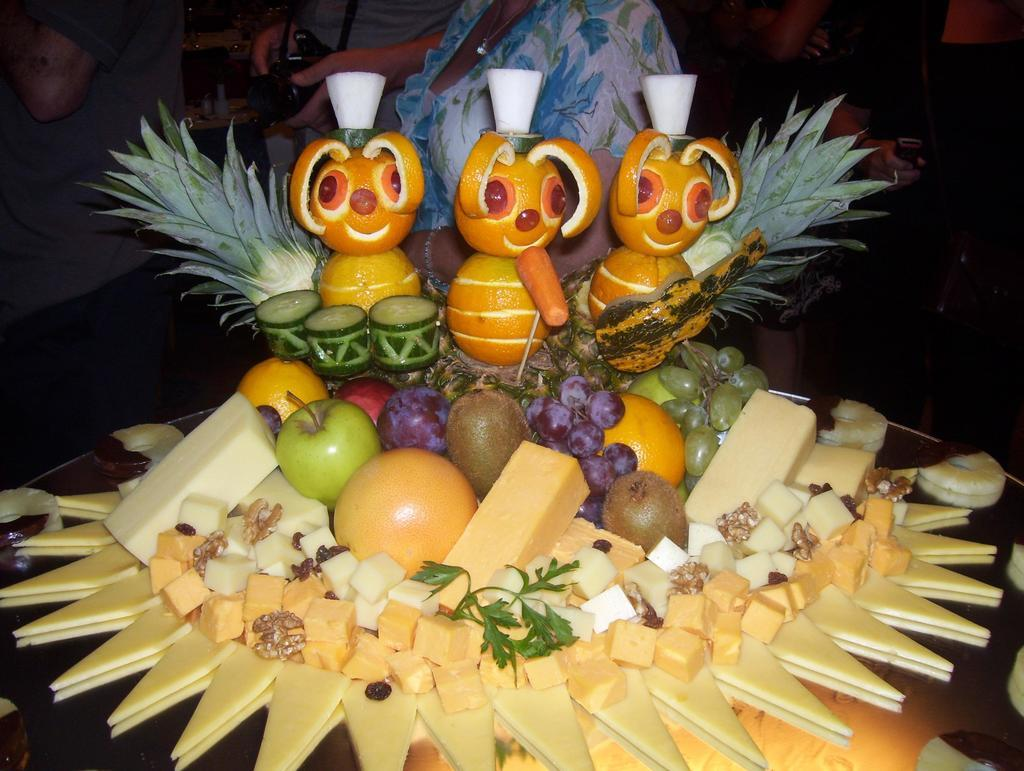What is the main subject of the image? There is a group of fruits on a platform in the image. Can you describe the setting of the image? There are people visible in the background of the image. What is one specific object present in the background? A camera is present in the background of the image. What else can be seen in the background? There are other objects in the background of the image. What type of pipe is being used to water the fruits in the image? There is no pipe or watering activity visible in the image; it only shows a group of fruits on a platform. 